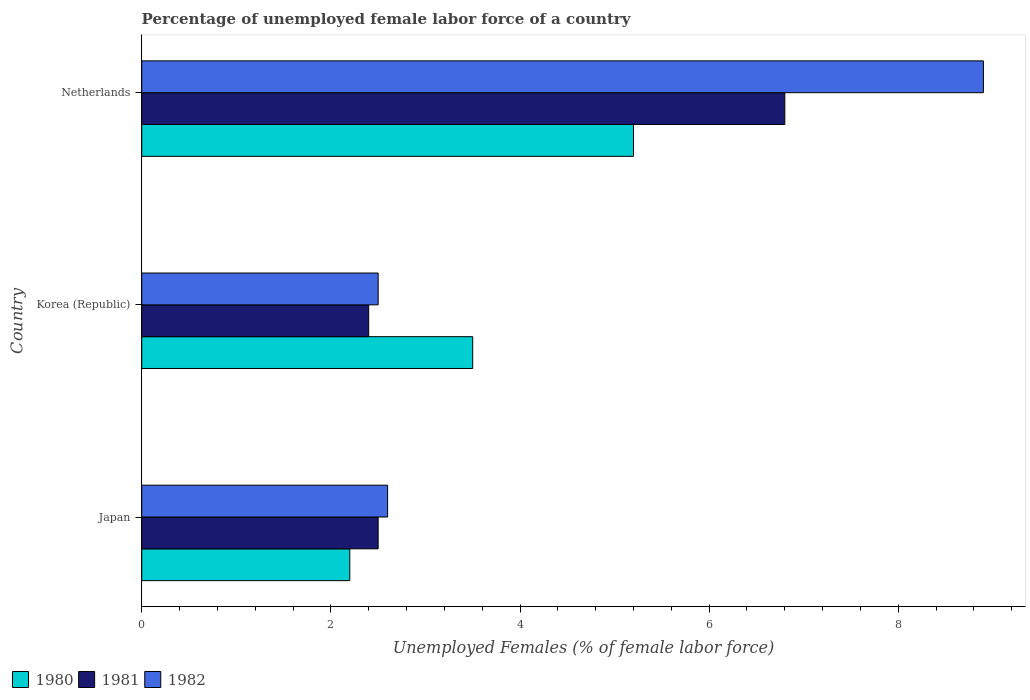Are the number of bars per tick equal to the number of legend labels?
Make the answer very short. Yes. Are the number of bars on each tick of the Y-axis equal?
Keep it short and to the point. Yes. What is the label of the 3rd group of bars from the top?
Give a very brief answer. Japan. What is the percentage of unemployed female labor force in 1980 in Netherlands?
Offer a very short reply. 5.2. Across all countries, what is the maximum percentage of unemployed female labor force in 1981?
Your answer should be compact. 6.8. Across all countries, what is the minimum percentage of unemployed female labor force in 1981?
Your response must be concise. 2.4. In which country was the percentage of unemployed female labor force in 1981 maximum?
Provide a short and direct response. Netherlands. What is the total percentage of unemployed female labor force in 1981 in the graph?
Your answer should be compact. 11.7. What is the difference between the percentage of unemployed female labor force in 1980 in Japan and that in Netherlands?
Your response must be concise. -3. What is the difference between the percentage of unemployed female labor force in 1982 in Netherlands and the percentage of unemployed female labor force in 1980 in Korea (Republic)?
Provide a succinct answer. 5.4. What is the average percentage of unemployed female labor force in 1980 per country?
Offer a terse response. 3.63. What is the difference between the percentage of unemployed female labor force in 1982 and percentage of unemployed female labor force in 1981 in Japan?
Make the answer very short. 0.1. In how many countries, is the percentage of unemployed female labor force in 1982 greater than 7.6 %?
Your response must be concise. 1. What is the ratio of the percentage of unemployed female labor force in 1982 in Japan to that in Netherlands?
Provide a succinct answer. 0.29. Is the difference between the percentage of unemployed female labor force in 1982 in Korea (Republic) and Netherlands greater than the difference between the percentage of unemployed female labor force in 1981 in Korea (Republic) and Netherlands?
Your response must be concise. No. What is the difference between the highest and the second highest percentage of unemployed female labor force in 1982?
Provide a short and direct response. 6.3. What is the difference between the highest and the lowest percentage of unemployed female labor force in 1981?
Offer a terse response. 4.4. In how many countries, is the percentage of unemployed female labor force in 1982 greater than the average percentage of unemployed female labor force in 1982 taken over all countries?
Keep it short and to the point. 1. What does the 3rd bar from the top in Korea (Republic) represents?
Offer a terse response. 1980. How many bars are there?
Ensure brevity in your answer.  9. Are all the bars in the graph horizontal?
Provide a short and direct response. Yes. How many countries are there in the graph?
Your response must be concise. 3. Does the graph contain any zero values?
Offer a very short reply. No. How many legend labels are there?
Ensure brevity in your answer.  3. How are the legend labels stacked?
Keep it short and to the point. Horizontal. What is the title of the graph?
Give a very brief answer. Percentage of unemployed female labor force of a country. What is the label or title of the X-axis?
Offer a terse response. Unemployed Females (% of female labor force). What is the label or title of the Y-axis?
Your answer should be compact. Country. What is the Unemployed Females (% of female labor force) in 1980 in Japan?
Provide a short and direct response. 2.2. What is the Unemployed Females (% of female labor force) in 1982 in Japan?
Your answer should be compact. 2.6. What is the Unemployed Females (% of female labor force) in 1980 in Korea (Republic)?
Offer a terse response. 3.5. What is the Unemployed Females (% of female labor force) in 1981 in Korea (Republic)?
Provide a short and direct response. 2.4. What is the Unemployed Females (% of female labor force) of 1982 in Korea (Republic)?
Ensure brevity in your answer.  2.5. What is the Unemployed Females (% of female labor force) of 1980 in Netherlands?
Ensure brevity in your answer.  5.2. What is the Unemployed Females (% of female labor force) in 1981 in Netherlands?
Offer a very short reply. 6.8. What is the Unemployed Females (% of female labor force) of 1982 in Netherlands?
Make the answer very short. 8.9. Across all countries, what is the maximum Unemployed Females (% of female labor force) in 1980?
Keep it short and to the point. 5.2. Across all countries, what is the maximum Unemployed Females (% of female labor force) of 1981?
Give a very brief answer. 6.8. Across all countries, what is the maximum Unemployed Females (% of female labor force) in 1982?
Give a very brief answer. 8.9. Across all countries, what is the minimum Unemployed Females (% of female labor force) in 1980?
Your response must be concise. 2.2. Across all countries, what is the minimum Unemployed Females (% of female labor force) of 1981?
Your answer should be very brief. 2.4. What is the total Unemployed Females (% of female labor force) of 1981 in the graph?
Provide a succinct answer. 11.7. What is the total Unemployed Females (% of female labor force) in 1982 in the graph?
Your response must be concise. 14. What is the difference between the Unemployed Females (% of female labor force) of 1980 in Japan and that in Korea (Republic)?
Offer a terse response. -1.3. What is the difference between the Unemployed Females (% of female labor force) of 1981 in Japan and that in Korea (Republic)?
Provide a succinct answer. 0.1. What is the difference between the Unemployed Females (% of female labor force) of 1980 in Japan and that in Netherlands?
Offer a terse response. -3. What is the difference between the Unemployed Females (% of female labor force) of 1981 in Japan and that in Netherlands?
Keep it short and to the point. -4.3. What is the difference between the Unemployed Females (% of female labor force) of 1982 in Japan and that in Netherlands?
Provide a succinct answer. -6.3. What is the difference between the Unemployed Females (% of female labor force) of 1980 in Korea (Republic) and that in Netherlands?
Your answer should be very brief. -1.7. What is the difference between the Unemployed Females (% of female labor force) of 1982 in Korea (Republic) and that in Netherlands?
Ensure brevity in your answer.  -6.4. What is the difference between the Unemployed Females (% of female labor force) in 1980 in Japan and the Unemployed Females (% of female labor force) in 1981 in Korea (Republic)?
Provide a succinct answer. -0.2. What is the difference between the Unemployed Females (% of female labor force) in 1980 in Japan and the Unemployed Females (% of female labor force) in 1982 in Korea (Republic)?
Offer a terse response. -0.3. What is the difference between the Unemployed Females (% of female labor force) in 1980 in Japan and the Unemployed Females (% of female labor force) in 1981 in Netherlands?
Offer a terse response. -4.6. What is the difference between the Unemployed Females (% of female labor force) in 1980 in Korea (Republic) and the Unemployed Females (% of female labor force) in 1981 in Netherlands?
Keep it short and to the point. -3.3. What is the difference between the Unemployed Females (% of female labor force) in 1981 in Korea (Republic) and the Unemployed Females (% of female labor force) in 1982 in Netherlands?
Keep it short and to the point. -6.5. What is the average Unemployed Females (% of female labor force) in 1980 per country?
Provide a succinct answer. 3.63. What is the average Unemployed Females (% of female labor force) of 1981 per country?
Provide a succinct answer. 3.9. What is the average Unemployed Females (% of female labor force) of 1982 per country?
Give a very brief answer. 4.67. What is the difference between the Unemployed Females (% of female labor force) in 1980 and Unemployed Females (% of female labor force) in 1981 in Japan?
Ensure brevity in your answer.  -0.3. What is the difference between the Unemployed Females (% of female labor force) of 1980 and Unemployed Females (% of female labor force) of 1982 in Japan?
Give a very brief answer. -0.4. What is the difference between the Unemployed Females (% of female labor force) of 1981 and Unemployed Females (% of female labor force) of 1982 in Japan?
Give a very brief answer. -0.1. What is the difference between the Unemployed Females (% of female labor force) in 1980 and Unemployed Females (% of female labor force) in 1981 in Korea (Republic)?
Provide a short and direct response. 1.1. What is the difference between the Unemployed Females (% of female labor force) of 1981 and Unemployed Females (% of female labor force) of 1982 in Korea (Republic)?
Your answer should be very brief. -0.1. What is the ratio of the Unemployed Females (% of female labor force) of 1980 in Japan to that in Korea (Republic)?
Your response must be concise. 0.63. What is the ratio of the Unemployed Females (% of female labor force) of 1981 in Japan to that in Korea (Republic)?
Offer a very short reply. 1.04. What is the ratio of the Unemployed Females (% of female labor force) in 1980 in Japan to that in Netherlands?
Offer a terse response. 0.42. What is the ratio of the Unemployed Females (% of female labor force) of 1981 in Japan to that in Netherlands?
Provide a short and direct response. 0.37. What is the ratio of the Unemployed Females (% of female labor force) in 1982 in Japan to that in Netherlands?
Provide a short and direct response. 0.29. What is the ratio of the Unemployed Females (% of female labor force) in 1980 in Korea (Republic) to that in Netherlands?
Make the answer very short. 0.67. What is the ratio of the Unemployed Females (% of female labor force) in 1981 in Korea (Republic) to that in Netherlands?
Ensure brevity in your answer.  0.35. What is the ratio of the Unemployed Females (% of female labor force) in 1982 in Korea (Republic) to that in Netherlands?
Your response must be concise. 0.28. What is the difference between the highest and the second highest Unemployed Females (% of female labor force) in 1981?
Provide a short and direct response. 4.3. What is the difference between the highest and the second highest Unemployed Females (% of female labor force) of 1982?
Offer a terse response. 6.3. What is the difference between the highest and the lowest Unemployed Females (% of female labor force) of 1980?
Your answer should be compact. 3. What is the difference between the highest and the lowest Unemployed Females (% of female labor force) in 1981?
Your answer should be very brief. 4.4. 